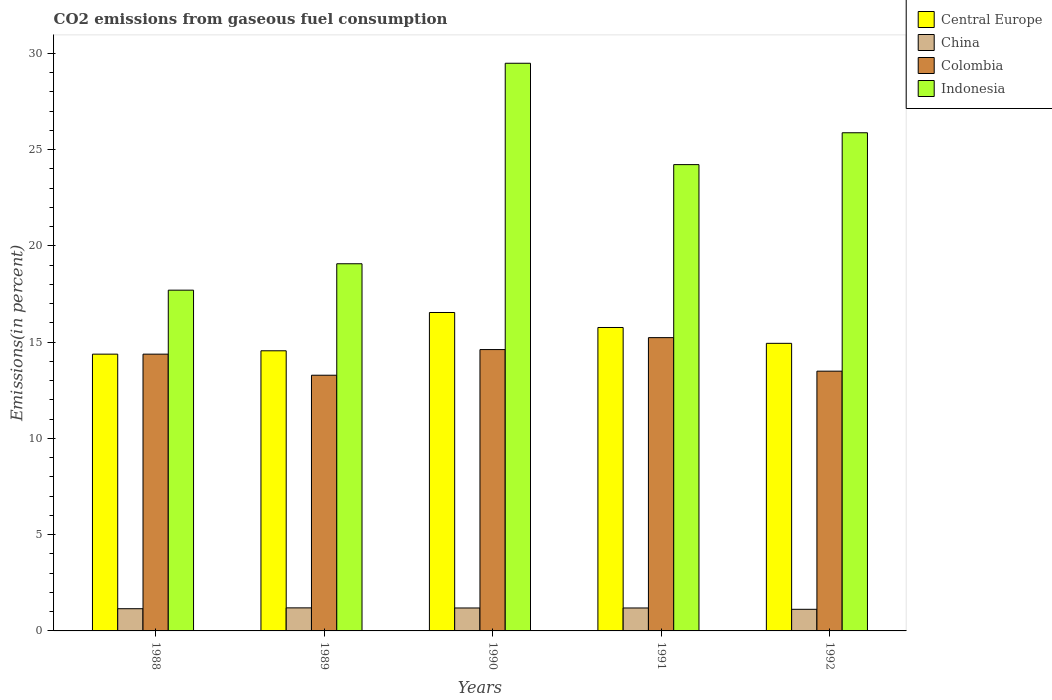How many different coloured bars are there?
Give a very brief answer. 4. How many groups of bars are there?
Your response must be concise. 5. What is the label of the 2nd group of bars from the left?
Offer a terse response. 1989. In how many cases, is the number of bars for a given year not equal to the number of legend labels?
Make the answer very short. 0. What is the total CO2 emitted in Central Europe in 1990?
Provide a succinct answer. 16.54. Across all years, what is the maximum total CO2 emitted in China?
Your response must be concise. 1.2. Across all years, what is the minimum total CO2 emitted in China?
Provide a succinct answer. 1.12. What is the total total CO2 emitted in Central Europe in the graph?
Your response must be concise. 76.16. What is the difference between the total CO2 emitted in Colombia in 1988 and that in 1991?
Offer a terse response. -0.86. What is the difference between the total CO2 emitted in Central Europe in 1992 and the total CO2 emitted in Colombia in 1990?
Provide a short and direct response. 0.32. What is the average total CO2 emitted in China per year?
Provide a succinct answer. 1.17. In the year 1988, what is the difference between the total CO2 emitted in China and total CO2 emitted in Indonesia?
Keep it short and to the point. -16.55. In how many years, is the total CO2 emitted in Indonesia greater than 11 %?
Offer a terse response. 5. What is the ratio of the total CO2 emitted in Indonesia in 1990 to that in 1992?
Provide a succinct answer. 1.14. What is the difference between the highest and the second highest total CO2 emitted in Colombia?
Make the answer very short. 0.62. What is the difference between the highest and the lowest total CO2 emitted in Colombia?
Keep it short and to the point. 1.95. In how many years, is the total CO2 emitted in China greater than the average total CO2 emitted in China taken over all years?
Provide a succinct answer. 3. Is the sum of the total CO2 emitted in Indonesia in 1988 and 1990 greater than the maximum total CO2 emitted in China across all years?
Make the answer very short. Yes. What does the 1st bar from the right in 1990 represents?
Make the answer very short. Indonesia. Is it the case that in every year, the sum of the total CO2 emitted in China and total CO2 emitted in Colombia is greater than the total CO2 emitted in Central Europe?
Provide a short and direct response. No. Are all the bars in the graph horizontal?
Your answer should be compact. No. What is the difference between two consecutive major ticks on the Y-axis?
Keep it short and to the point. 5. Are the values on the major ticks of Y-axis written in scientific E-notation?
Ensure brevity in your answer.  No. Does the graph contain any zero values?
Offer a very short reply. No. Where does the legend appear in the graph?
Your answer should be very brief. Top right. How many legend labels are there?
Provide a short and direct response. 4. What is the title of the graph?
Provide a short and direct response. CO2 emissions from gaseous fuel consumption. Does "Lesotho" appear as one of the legend labels in the graph?
Provide a succinct answer. No. What is the label or title of the Y-axis?
Offer a very short reply. Emissions(in percent). What is the Emissions(in percent) of Central Europe in 1988?
Ensure brevity in your answer.  14.38. What is the Emissions(in percent) in China in 1988?
Offer a very short reply. 1.15. What is the Emissions(in percent) in Colombia in 1988?
Offer a terse response. 14.38. What is the Emissions(in percent) in Indonesia in 1988?
Make the answer very short. 17.7. What is the Emissions(in percent) in Central Europe in 1989?
Provide a short and direct response. 14.55. What is the Emissions(in percent) of China in 1989?
Make the answer very short. 1.2. What is the Emissions(in percent) in Colombia in 1989?
Your answer should be very brief. 13.28. What is the Emissions(in percent) of Indonesia in 1989?
Make the answer very short. 19.07. What is the Emissions(in percent) in Central Europe in 1990?
Make the answer very short. 16.54. What is the Emissions(in percent) of China in 1990?
Your response must be concise. 1.19. What is the Emissions(in percent) of Colombia in 1990?
Keep it short and to the point. 14.61. What is the Emissions(in percent) in Indonesia in 1990?
Make the answer very short. 29.48. What is the Emissions(in percent) of Central Europe in 1991?
Provide a succinct answer. 15.76. What is the Emissions(in percent) of China in 1991?
Offer a very short reply. 1.19. What is the Emissions(in percent) in Colombia in 1991?
Give a very brief answer. 15.23. What is the Emissions(in percent) of Indonesia in 1991?
Provide a short and direct response. 24.22. What is the Emissions(in percent) in Central Europe in 1992?
Your answer should be very brief. 14.94. What is the Emissions(in percent) of China in 1992?
Your answer should be very brief. 1.12. What is the Emissions(in percent) of Colombia in 1992?
Provide a succinct answer. 13.49. What is the Emissions(in percent) of Indonesia in 1992?
Keep it short and to the point. 25.87. Across all years, what is the maximum Emissions(in percent) in Central Europe?
Your response must be concise. 16.54. Across all years, what is the maximum Emissions(in percent) in China?
Your answer should be compact. 1.2. Across all years, what is the maximum Emissions(in percent) of Colombia?
Make the answer very short. 15.23. Across all years, what is the maximum Emissions(in percent) in Indonesia?
Offer a very short reply. 29.48. Across all years, what is the minimum Emissions(in percent) in Central Europe?
Ensure brevity in your answer.  14.38. Across all years, what is the minimum Emissions(in percent) in China?
Ensure brevity in your answer.  1.12. Across all years, what is the minimum Emissions(in percent) in Colombia?
Your answer should be very brief. 13.28. Across all years, what is the minimum Emissions(in percent) of Indonesia?
Your answer should be compact. 17.7. What is the total Emissions(in percent) of Central Europe in the graph?
Offer a terse response. 76.16. What is the total Emissions(in percent) of China in the graph?
Keep it short and to the point. 5.86. What is the total Emissions(in percent) in Colombia in the graph?
Offer a very short reply. 71. What is the total Emissions(in percent) of Indonesia in the graph?
Your response must be concise. 116.35. What is the difference between the Emissions(in percent) of Central Europe in 1988 and that in 1989?
Provide a succinct answer. -0.17. What is the difference between the Emissions(in percent) of China in 1988 and that in 1989?
Offer a very short reply. -0.04. What is the difference between the Emissions(in percent) in Colombia in 1988 and that in 1989?
Provide a short and direct response. 1.09. What is the difference between the Emissions(in percent) in Indonesia in 1988 and that in 1989?
Make the answer very short. -1.37. What is the difference between the Emissions(in percent) in Central Europe in 1988 and that in 1990?
Offer a terse response. -2.16. What is the difference between the Emissions(in percent) of China in 1988 and that in 1990?
Your response must be concise. -0.04. What is the difference between the Emissions(in percent) in Colombia in 1988 and that in 1990?
Provide a short and direct response. -0.24. What is the difference between the Emissions(in percent) in Indonesia in 1988 and that in 1990?
Offer a terse response. -11.79. What is the difference between the Emissions(in percent) of Central Europe in 1988 and that in 1991?
Provide a succinct answer. -1.39. What is the difference between the Emissions(in percent) of China in 1988 and that in 1991?
Your answer should be compact. -0.04. What is the difference between the Emissions(in percent) in Colombia in 1988 and that in 1991?
Give a very brief answer. -0.86. What is the difference between the Emissions(in percent) of Indonesia in 1988 and that in 1991?
Offer a terse response. -6.52. What is the difference between the Emissions(in percent) of Central Europe in 1988 and that in 1992?
Make the answer very short. -0.56. What is the difference between the Emissions(in percent) of China in 1988 and that in 1992?
Your answer should be very brief. 0.03. What is the difference between the Emissions(in percent) of Colombia in 1988 and that in 1992?
Make the answer very short. 0.88. What is the difference between the Emissions(in percent) of Indonesia in 1988 and that in 1992?
Offer a very short reply. -8.18. What is the difference between the Emissions(in percent) in Central Europe in 1989 and that in 1990?
Offer a very short reply. -1.99. What is the difference between the Emissions(in percent) in China in 1989 and that in 1990?
Give a very brief answer. 0.01. What is the difference between the Emissions(in percent) in Colombia in 1989 and that in 1990?
Your answer should be compact. -1.33. What is the difference between the Emissions(in percent) of Indonesia in 1989 and that in 1990?
Offer a terse response. -10.41. What is the difference between the Emissions(in percent) of Central Europe in 1989 and that in 1991?
Make the answer very short. -1.21. What is the difference between the Emissions(in percent) in China in 1989 and that in 1991?
Your response must be concise. 0.01. What is the difference between the Emissions(in percent) of Colombia in 1989 and that in 1991?
Provide a short and direct response. -1.95. What is the difference between the Emissions(in percent) in Indonesia in 1989 and that in 1991?
Provide a short and direct response. -5.15. What is the difference between the Emissions(in percent) in Central Europe in 1989 and that in 1992?
Your answer should be very brief. -0.39. What is the difference between the Emissions(in percent) in China in 1989 and that in 1992?
Your answer should be very brief. 0.07. What is the difference between the Emissions(in percent) of Colombia in 1989 and that in 1992?
Your answer should be very brief. -0.21. What is the difference between the Emissions(in percent) of Indonesia in 1989 and that in 1992?
Provide a short and direct response. -6.8. What is the difference between the Emissions(in percent) in Central Europe in 1990 and that in 1991?
Offer a terse response. 0.78. What is the difference between the Emissions(in percent) of China in 1990 and that in 1991?
Offer a very short reply. -0. What is the difference between the Emissions(in percent) in Colombia in 1990 and that in 1991?
Offer a very short reply. -0.62. What is the difference between the Emissions(in percent) of Indonesia in 1990 and that in 1991?
Your response must be concise. 5.26. What is the difference between the Emissions(in percent) of Central Europe in 1990 and that in 1992?
Offer a very short reply. 1.6. What is the difference between the Emissions(in percent) of China in 1990 and that in 1992?
Offer a terse response. 0.07. What is the difference between the Emissions(in percent) in Colombia in 1990 and that in 1992?
Provide a succinct answer. 1.12. What is the difference between the Emissions(in percent) of Indonesia in 1990 and that in 1992?
Your answer should be very brief. 3.61. What is the difference between the Emissions(in percent) of Central Europe in 1991 and that in 1992?
Offer a terse response. 0.82. What is the difference between the Emissions(in percent) in China in 1991 and that in 1992?
Your answer should be very brief. 0.07. What is the difference between the Emissions(in percent) in Colombia in 1991 and that in 1992?
Provide a short and direct response. 1.74. What is the difference between the Emissions(in percent) of Indonesia in 1991 and that in 1992?
Keep it short and to the point. -1.65. What is the difference between the Emissions(in percent) of Central Europe in 1988 and the Emissions(in percent) of China in 1989?
Provide a short and direct response. 13.18. What is the difference between the Emissions(in percent) of Central Europe in 1988 and the Emissions(in percent) of Colombia in 1989?
Make the answer very short. 1.09. What is the difference between the Emissions(in percent) in Central Europe in 1988 and the Emissions(in percent) in Indonesia in 1989?
Provide a succinct answer. -4.69. What is the difference between the Emissions(in percent) of China in 1988 and the Emissions(in percent) of Colombia in 1989?
Ensure brevity in your answer.  -12.13. What is the difference between the Emissions(in percent) of China in 1988 and the Emissions(in percent) of Indonesia in 1989?
Ensure brevity in your answer.  -17.92. What is the difference between the Emissions(in percent) of Colombia in 1988 and the Emissions(in percent) of Indonesia in 1989?
Provide a short and direct response. -4.69. What is the difference between the Emissions(in percent) of Central Europe in 1988 and the Emissions(in percent) of China in 1990?
Provide a short and direct response. 13.18. What is the difference between the Emissions(in percent) of Central Europe in 1988 and the Emissions(in percent) of Colombia in 1990?
Your answer should be very brief. -0.24. What is the difference between the Emissions(in percent) in Central Europe in 1988 and the Emissions(in percent) in Indonesia in 1990?
Offer a terse response. -15.11. What is the difference between the Emissions(in percent) of China in 1988 and the Emissions(in percent) of Colombia in 1990?
Ensure brevity in your answer.  -13.46. What is the difference between the Emissions(in percent) of China in 1988 and the Emissions(in percent) of Indonesia in 1990?
Give a very brief answer. -28.33. What is the difference between the Emissions(in percent) in Colombia in 1988 and the Emissions(in percent) in Indonesia in 1990?
Give a very brief answer. -15.11. What is the difference between the Emissions(in percent) of Central Europe in 1988 and the Emissions(in percent) of China in 1991?
Ensure brevity in your answer.  13.18. What is the difference between the Emissions(in percent) of Central Europe in 1988 and the Emissions(in percent) of Colombia in 1991?
Your response must be concise. -0.86. What is the difference between the Emissions(in percent) in Central Europe in 1988 and the Emissions(in percent) in Indonesia in 1991?
Your answer should be compact. -9.84. What is the difference between the Emissions(in percent) in China in 1988 and the Emissions(in percent) in Colombia in 1991?
Make the answer very short. -14.08. What is the difference between the Emissions(in percent) of China in 1988 and the Emissions(in percent) of Indonesia in 1991?
Offer a terse response. -23.07. What is the difference between the Emissions(in percent) of Colombia in 1988 and the Emissions(in percent) of Indonesia in 1991?
Your response must be concise. -9.84. What is the difference between the Emissions(in percent) in Central Europe in 1988 and the Emissions(in percent) in China in 1992?
Make the answer very short. 13.25. What is the difference between the Emissions(in percent) of Central Europe in 1988 and the Emissions(in percent) of Colombia in 1992?
Provide a short and direct response. 0.88. What is the difference between the Emissions(in percent) in Central Europe in 1988 and the Emissions(in percent) in Indonesia in 1992?
Your answer should be compact. -11.5. What is the difference between the Emissions(in percent) of China in 1988 and the Emissions(in percent) of Colombia in 1992?
Provide a short and direct response. -12.34. What is the difference between the Emissions(in percent) of China in 1988 and the Emissions(in percent) of Indonesia in 1992?
Make the answer very short. -24.72. What is the difference between the Emissions(in percent) of Colombia in 1988 and the Emissions(in percent) of Indonesia in 1992?
Provide a succinct answer. -11.5. What is the difference between the Emissions(in percent) in Central Europe in 1989 and the Emissions(in percent) in China in 1990?
Give a very brief answer. 13.36. What is the difference between the Emissions(in percent) in Central Europe in 1989 and the Emissions(in percent) in Colombia in 1990?
Keep it short and to the point. -0.06. What is the difference between the Emissions(in percent) in Central Europe in 1989 and the Emissions(in percent) in Indonesia in 1990?
Your response must be concise. -14.93. What is the difference between the Emissions(in percent) of China in 1989 and the Emissions(in percent) of Colombia in 1990?
Give a very brief answer. -13.42. What is the difference between the Emissions(in percent) in China in 1989 and the Emissions(in percent) in Indonesia in 1990?
Make the answer very short. -28.29. What is the difference between the Emissions(in percent) in Colombia in 1989 and the Emissions(in percent) in Indonesia in 1990?
Your answer should be very brief. -16.2. What is the difference between the Emissions(in percent) in Central Europe in 1989 and the Emissions(in percent) in China in 1991?
Make the answer very short. 13.36. What is the difference between the Emissions(in percent) of Central Europe in 1989 and the Emissions(in percent) of Colombia in 1991?
Your response must be concise. -0.68. What is the difference between the Emissions(in percent) in Central Europe in 1989 and the Emissions(in percent) in Indonesia in 1991?
Offer a terse response. -9.67. What is the difference between the Emissions(in percent) in China in 1989 and the Emissions(in percent) in Colombia in 1991?
Give a very brief answer. -14.04. What is the difference between the Emissions(in percent) in China in 1989 and the Emissions(in percent) in Indonesia in 1991?
Make the answer very short. -23.02. What is the difference between the Emissions(in percent) in Colombia in 1989 and the Emissions(in percent) in Indonesia in 1991?
Ensure brevity in your answer.  -10.94. What is the difference between the Emissions(in percent) of Central Europe in 1989 and the Emissions(in percent) of China in 1992?
Ensure brevity in your answer.  13.43. What is the difference between the Emissions(in percent) in Central Europe in 1989 and the Emissions(in percent) in Colombia in 1992?
Offer a very short reply. 1.06. What is the difference between the Emissions(in percent) in Central Europe in 1989 and the Emissions(in percent) in Indonesia in 1992?
Offer a terse response. -11.32. What is the difference between the Emissions(in percent) in China in 1989 and the Emissions(in percent) in Colombia in 1992?
Offer a terse response. -12.29. What is the difference between the Emissions(in percent) of China in 1989 and the Emissions(in percent) of Indonesia in 1992?
Offer a very short reply. -24.68. What is the difference between the Emissions(in percent) in Colombia in 1989 and the Emissions(in percent) in Indonesia in 1992?
Keep it short and to the point. -12.59. What is the difference between the Emissions(in percent) in Central Europe in 1990 and the Emissions(in percent) in China in 1991?
Provide a succinct answer. 15.35. What is the difference between the Emissions(in percent) in Central Europe in 1990 and the Emissions(in percent) in Colombia in 1991?
Provide a succinct answer. 1.31. What is the difference between the Emissions(in percent) in Central Europe in 1990 and the Emissions(in percent) in Indonesia in 1991?
Offer a very short reply. -7.68. What is the difference between the Emissions(in percent) in China in 1990 and the Emissions(in percent) in Colombia in 1991?
Your answer should be compact. -14.04. What is the difference between the Emissions(in percent) in China in 1990 and the Emissions(in percent) in Indonesia in 1991?
Your answer should be very brief. -23.03. What is the difference between the Emissions(in percent) in Colombia in 1990 and the Emissions(in percent) in Indonesia in 1991?
Your answer should be very brief. -9.61. What is the difference between the Emissions(in percent) of Central Europe in 1990 and the Emissions(in percent) of China in 1992?
Keep it short and to the point. 15.42. What is the difference between the Emissions(in percent) in Central Europe in 1990 and the Emissions(in percent) in Colombia in 1992?
Keep it short and to the point. 3.05. What is the difference between the Emissions(in percent) of Central Europe in 1990 and the Emissions(in percent) of Indonesia in 1992?
Provide a short and direct response. -9.34. What is the difference between the Emissions(in percent) in China in 1990 and the Emissions(in percent) in Colombia in 1992?
Offer a very short reply. -12.3. What is the difference between the Emissions(in percent) of China in 1990 and the Emissions(in percent) of Indonesia in 1992?
Give a very brief answer. -24.68. What is the difference between the Emissions(in percent) in Colombia in 1990 and the Emissions(in percent) in Indonesia in 1992?
Provide a succinct answer. -11.26. What is the difference between the Emissions(in percent) of Central Europe in 1991 and the Emissions(in percent) of China in 1992?
Offer a terse response. 14.64. What is the difference between the Emissions(in percent) of Central Europe in 1991 and the Emissions(in percent) of Colombia in 1992?
Offer a terse response. 2.27. What is the difference between the Emissions(in percent) of Central Europe in 1991 and the Emissions(in percent) of Indonesia in 1992?
Your answer should be very brief. -10.11. What is the difference between the Emissions(in percent) in China in 1991 and the Emissions(in percent) in Colombia in 1992?
Offer a terse response. -12.3. What is the difference between the Emissions(in percent) in China in 1991 and the Emissions(in percent) in Indonesia in 1992?
Provide a short and direct response. -24.68. What is the difference between the Emissions(in percent) of Colombia in 1991 and the Emissions(in percent) of Indonesia in 1992?
Your response must be concise. -10.64. What is the average Emissions(in percent) of Central Europe per year?
Your answer should be compact. 15.23. What is the average Emissions(in percent) in China per year?
Your response must be concise. 1.17. What is the average Emissions(in percent) in Colombia per year?
Keep it short and to the point. 14.2. What is the average Emissions(in percent) of Indonesia per year?
Provide a short and direct response. 23.27. In the year 1988, what is the difference between the Emissions(in percent) in Central Europe and Emissions(in percent) in China?
Offer a terse response. 13.22. In the year 1988, what is the difference between the Emissions(in percent) in Central Europe and Emissions(in percent) in Indonesia?
Make the answer very short. -3.32. In the year 1988, what is the difference between the Emissions(in percent) of China and Emissions(in percent) of Colombia?
Give a very brief answer. -13.22. In the year 1988, what is the difference between the Emissions(in percent) of China and Emissions(in percent) of Indonesia?
Your response must be concise. -16.55. In the year 1988, what is the difference between the Emissions(in percent) in Colombia and Emissions(in percent) in Indonesia?
Ensure brevity in your answer.  -3.32. In the year 1989, what is the difference between the Emissions(in percent) of Central Europe and Emissions(in percent) of China?
Your response must be concise. 13.35. In the year 1989, what is the difference between the Emissions(in percent) in Central Europe and Emissions(in percent) in Colombia?
Give a very brief answer. 1.27. In the year 1989, what is the difference between the Emissions(in percent) of Central Europe and Emissions(in percent) of Indonesia?
Your response must be concise. -4.52. In the year 1989, what is the difference between the Emissions(in percent) in China and Emissions(in percent) in Colombia?
Ensure brevity in your answer.  -12.08. In the year 1989, what is the difference between the Emissions(in percent) in China and Emissions(in percent) in Indonesia?
Offer a very short reply. -17.87. In the year 1989, what is the difference between the Emissions(in percent) in Colombia and Emissions(in percent) in Indonesia?
Your answer should be compact. -5.79. In the year 1990, what is the difference between the Emissions(in percent) in Central Europe and Emissions(in percent) in China?
Your response must be concise. 15.35. In the year 1990, what is the difference between the Emissions(in percent) in Central Europe and Emissions(in percent) in Colombia?
Ensure brevity in your answer.  1.93. In the year 1990, what is the difference between the Emissions(in percent) in Central Europe and Emissions(in percent) in Indonesia?
Keep it short and to the point. -12.95. In the year 1990, what is the difference between the Emissions(in percent) of China and Emissions(in percent) of Colombia?
Offer a very short reply. -13.42. In the year 1990, what is the difference between the Emissions(in percent) of China and Emissions(in percent) of Indonesia?
Offer a very short reply. -28.29. In the year 1990, what is the difference between the Emissions(in percent) of Colombia and Emissions(in percent) of Indonesia?
Make the answer very short. -14.87. In the year 1991, what is the difference between the Emissions(in percent) of Central Europe and Emissions(in percent) of China?
Offer a very short reply. 14.57. In the year 1991, what is the difference between the Emissions(in percent) in Central Europe and Emissions(in percent) in Colombia?
Your answer should be compact. 0.53. In the year 1991, what is the difference between the Emissions(in percent) in Central Europe and Emissions(in percent) in Indonesia?
Offer a terse response. -8.46. In the year 1991, what is the difference between the Emissions(in percent) of China and Emissions(in percent) of Colombia?
Offer a very short reply. -14.04. In the year 1991, what is the difference between the Emissions(in percent) in China and Emissions(in percent) in Indonesia?
Make the answer very short. -23.03. In the year 1991, what is the difference between the Emissions(in percent) in Colombia and Emissions(in percent) in Indonesia?
Give a very brief answer. -8.99. In the year 1992, what is the difference between the Emissions(in percent) of Central Europe and Emissions(in percent) of China?
Your answer should be compact. 13.81. In the year 1992, what is the difference between the Emissions(in percent) in Central Europe and Emissions(in percent) in Colombia?
Make the answer very short. 1.45. In the year 1992, what is the difference between the Emissions(in percent) of Central Europe and Emissions(in percent) of Indonesia?
Your answer should be compact. -10.94. In the year 1992, what is the difference between the Emissions(in percent) in China and Emissions(in percent) in Colombia?
Make the answer very short. -12.37. In the year 1992, what is the difference between the Emissions(in percent) in China and Emissions(in percent) in Indonesia?
Your answer should be compact. -24.75. In the year 1992, what is the difference between the Emissions(in percent) of Colombia and Emissions(in percent) of Indonesia?
Make the answer very short. -12.38. What is the ratio of the Emissions(in percent) in China in 1988 to that in 1989?
Offer a terse response. 0.96. What is the ratio of the Emissions(in percent) of Colombia in 1988 to that in 1989?
Make the answer very short. 1.08. What is the ratio of the Emissions(in percent) in Indonesia in 1988 to that in 1989?
Provide a succinct answer. 0.93. What is the ratio of the Emissions(in percent) of Central Europe in 1988 to that in 1990?
Offer a terse response. 0.87. What is the ratio of the Emissions(in percent) in China in 1988 to that in 1990?
Your answer should be compact. 0.97. What is the ratio of the Emissions(in percent) in Colombia in 1988 to that in 1990?
Give a very brief answer. 0.98. What is the ratio of the Emissions(in percent) in Indonesia in 1988 to that in 1990?
Make the answer very short. 0.6. What is the ratio of the Emissions(in percent) of Central Europe in 1988 to that in 1991?
Your response must be concise. 0.91. What is the ratio of the Emissions(in percent) in China in 1988 to that in 1991?
Your answer should be compact. 0.97. What is the ratio of the Emissions(in percent) in Colombia in 1988 to that in 1991?
Your answer should be compact. 0.94. What is the ratio of the Emissions(in percent) in Indonesia in 1988 to that in 1991?
Offer a terse response. 0.73. What is the ratio of the Emissions(in percent) in Central Europe in 1988 to that in 1992?
Provide a short and direct response. 0.96. What is the ratio of the Emissions(in percent) in China in 1988 to that in 1992?
Make the answer very short. 1.03. What is the ratio of the Emissions(in percent) in Colombia in 1988 to that in 1992?
Make the answer very short. 1.07. What is the ratio of the Emissions(in percent) in Indonesia in 1988 to that in 1992?
Offer a terse response. 0.68. What is the ratio of the Emissions(in percent) of Central Europe in 1989 to that in 1990?
Offer a terse response. 0.88. What is the ratio of the Emissions(in percent) in China in 1989 to that in 1990?
Offer a terse response. 1. What is the ratio of the Emissions(in percent) of Colombia in 1989 to that in 1990?
Your answer should be compact. 0.91. What is the ratio of the Emissions(in percent) in Indonesia in 1989 to that in 1990?
Keep it short and to the point. 0.65. What is the ratio of the Emissions(in percent) in Central Europe in 1989 to that in 1991?
Keep it short and to the point. 0.92. What is the ratio of the Emissions(in percent) in Colombia in 1989 to that in 1991?
Provide a succinct answer. 0.87. What is the ratio of the Emissions(in percent) in Indonesia in 1989 to that in 1991?
Provide a short and direct response. 0.79. What is the ratio of the Emissions(in percent) in Central Europe in 1989 to that in 1992?
Your answer should be compact. 0.97. What is the ratio of the Emissions(in percent) in China in 1989 to that in 1992?
Give a very brief answer. 1.07. What is the ratio of the Emissions(in percent) of Colombia in 1989 to that in 1992?
Ensure brevity in your answer.  0.98. What is the ratio of the Emissions(in percent) in Indonesia in 1989 to that in 1992?
Your answer should be very brief. 0.74. What is the ratio of the Emissions(in percent) of Central Europe in 1990 to that in 1991?
Ensure brevity in your answer.  1.05. What is the ratio of the Emissions(in percent) of China in 1990 to that in 1991?
Provide a short and direct response. 1. What is the ratio of the Emissions(in percent) of Colombia in 1990 to that in 1991?
Make the answer very short. 0.96. What is the ratio of the Emissions(in percent) of Indonesia in 1990 to that in 1991?
Keep it short and to the point. 1.22. What is the ratio of the Emissions(in percent) in Central Europe in 1990 to that in 1992?
Provide a short and direct response. 1.11. What is the ratio of the Emissions(in percent) of China in 1990 to that in 1992?
Provide a succinct answer. 1.06. What is the ratio of the Emissions(in percent) in Colombia in 1990 to that in 1992?
Make the answer very short. 1.08. What is the ratio of the Emissions(in percent) in Indonesia in 1990 to that in 1992?
Keep it short and to the point. 1.14. What is the ratio of the Emissions(in percent) in Central Europe in 1991 to that in 1992?
Your answer should be compact. 1.06. What is the ratio of the Emissions(in percent) in China in 1991 to that in 1992?
Make the answer very short. 1.06. What is the ratio of the Emissions(in percent) of Colombia in 1991 to that in 1992?
Make the answer very short. 1.13. What is the ratio of the Emissions(in percent) in Indonesia in 1991 to that in 1992?
Provide a short and direct response. 0.94. What is the difference between the highest and the second highest Emissions(in percent) in Central Europe?
Your response must be concise. 0.78. What is the difference between the highest and the second highest Emissions(in percent) of China?
Give a very brief answer. 0.01. What is the difference between the highest and the second highest Emissions(in percent) in Colombia?
Your response must be concise. 0.62. What is the difference between the highest and the second highest Emissions(in percent) in Indonesia?
Your answer should be compact. 3.61. What is the difference between the highest and the lowest Emissions(in percent) in Central Europe?
Make the answer very short. 2.16. What is the difference between the highest and the lowest Emissions(in percent) in China?
Offer a terse response. 0.07. What is the difference between the highest and the lowest Emissions(in percent) in Colombia?
Your answer should be compact. 1.95. What is the difference between the highest and the lowest Emissions(in percent) in Indonesia?
Give a very brief answer. 11.79. 